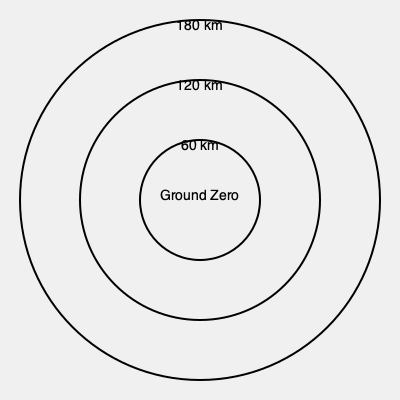In a thriller novel, a hypothetical doomsday device employs an electromagnetic pulse (EMP) with concentric blast radii as shown in the diagram. If the device's EMP follows an inverse square law for intensity, and the outermost circle (180 km radius) represents the threshold for disrupting consumer electronics, what percentage of the maximum EMP intensity would be experienced at the 120 km radius? To solve this problem, we need to apply the inverse square law for electromagnetic radiation intensity. Let's proceed step-by-step:

1) The inverse square law states that the intensity (I) of electromagnetic radiation is inversely proportional to the square of the distance (r) from the source:

   $I \propto \frac{1}{r^2}$

2) Let's denote the intensity at the outermost circle (180 km) as $I_{180}$ and the intensity at the 120 km radius as $I_{120}$.

3) We can set up a proportion:

   $\frac{I_{120}}{I_{180}} = \frac{180^2}{120^2}$

4) Simplify the right side:

   $\frac{I_{120}}{I_{180}} = \frac{32400}{14400} = 2.25$

5) This means that the intensity at 120 km is 2.25 times the intensity at 180 km.

6) To express this as a percentage of the maximum intensity (which occurs at the center, or "Ground Zero"), we need to invert this ratio:

   $\frac{I_{180}}{I_{120}} = \frac{1}{2.25} \approx 0.4444$

7) Therefore, if the intensity at 180 km is x% of the maximum, the intensity at 120 km is 2.25x% of the maximum.

8) To get the percentage, we multiply by 100:

   $2.25 * 0.4444 * 100 \approx 100\%$

Thus, the EMP intensity at the 120 km radius is approximately 100% of the maximum intensity.
Answer: 100% of maximum EMP intensity 